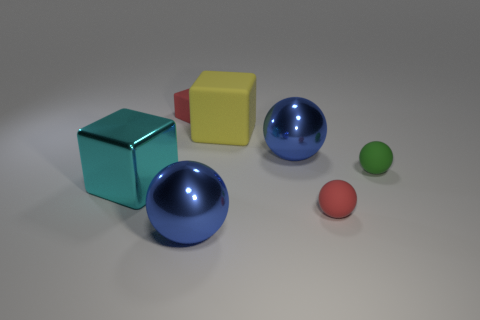Subtract all cyan metal blocks. How many blocks are left? 2 Subtract all red blocks. How many blue spheres are left? 2 Subtract all red cubes. How many cubes are left? 2 Subtract all cubes. How many objects are left? 4 Add 1 blue shiny objects. How many objects exist? 8 Subtract 2 spheres. How many spheres are left? 2 Subtract all big blue metallic things. Subtract all large cyan cubes. How many objects are left? 4 Add 7 tiny rubber things. How many tiny rubber things are left? 10 Add 5 rubber cubes. How many rubber cubes exist? 7 Subtract 0 purple cubes. How many objects are left? 7 